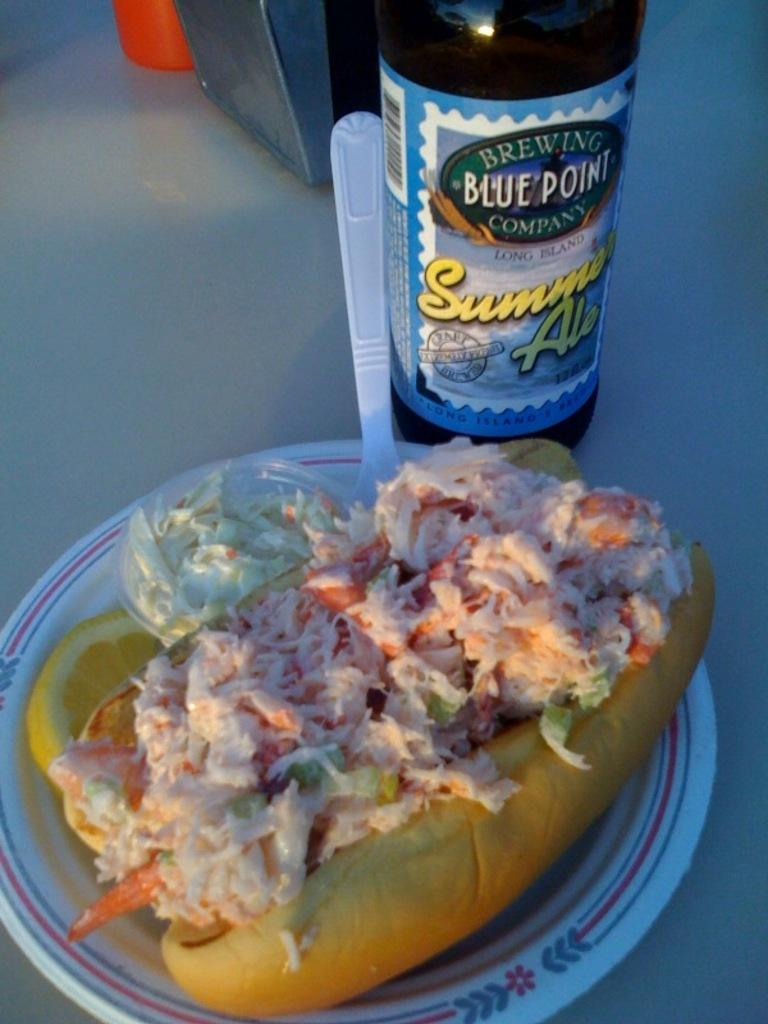<image>
Present a compact description of the photo's key features. A bottle of Blue Point Brewery Company summer ale sits next to a sandwich. 